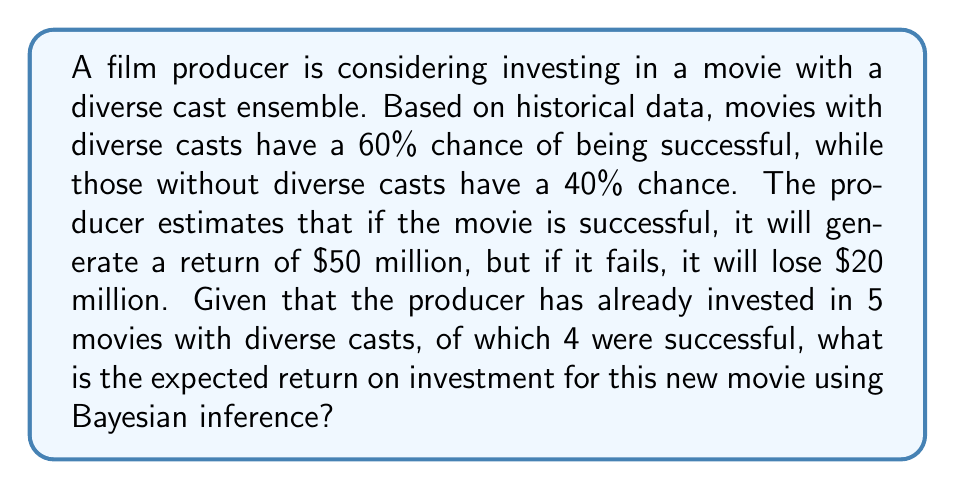Can you solve this math problem? Let's approach this step-by-step using Bayesian inference:

1) Define our prior probability:
   $P(success) = 0.60$ (initial belief based on historical data)

2) Calculate the likelihood of our observed data:
   $P(data|success) = \binom{5}{4} * 0.60^4 * 0.40^1 = 0.3456$
   
   $P(data|failure) = \binom{5}{1} * 0.40^4 * 0.60^1 = 0.0154$

3) Calculate the marginal likelihood:
   $P(data) = P(data|success) * P(success) + P(data|failure) * P(failure)$
   $= 0.3456 * 0.60 + 0.0154 * 0.40 = 0.2136$

4) Apply Bayes' theorem to get the posterior probability:
   $P(success|data) = \frac{P(data|success) * P(success)}{P(data)}$
   $= \frac{0.3456 * 0.60}{0.2136} = 0.9701$

5) Calculate the expected return:
   $E(return) = P(success|data) * (return_{success}) + (1 - P(success|data)) * (return_{failure})$
   $= 0.9701 * 50,000,000 + (1 - 0.9701) * (-20,000,000)$
   $= 48,505,000 - 599,400 = 47,905,600$

Therefore, the expected return on investment for this new movie is $47,905,600.
Answer: $47,905,600 